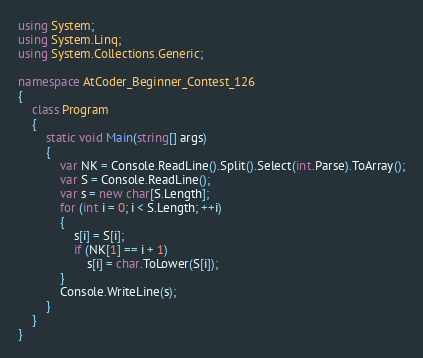<code> <loc_0><loc_0><loc_500><loc_500><_C#_>using System;
using System.Linq;
using System.Collections.Generic;

namespace AtCoder_Beginner_Contest_126
{
    class Program
    {
        static void Main(string[] args)
        {
            var NK = Console.ReadLine().Split().Select(int.Parse).ToArray();
            var S = Console.ReadLine();
            var s = new char[S.Length];
            for (int i = 0; i < S.Length; ++i)
            {
                s[i] = S[i];
                if (NK[1] == i + 1)
                    s[i] = char.ToLower(S[i]);
            }           
            Console.WriteLine(s);
        }
    }
}</code> 